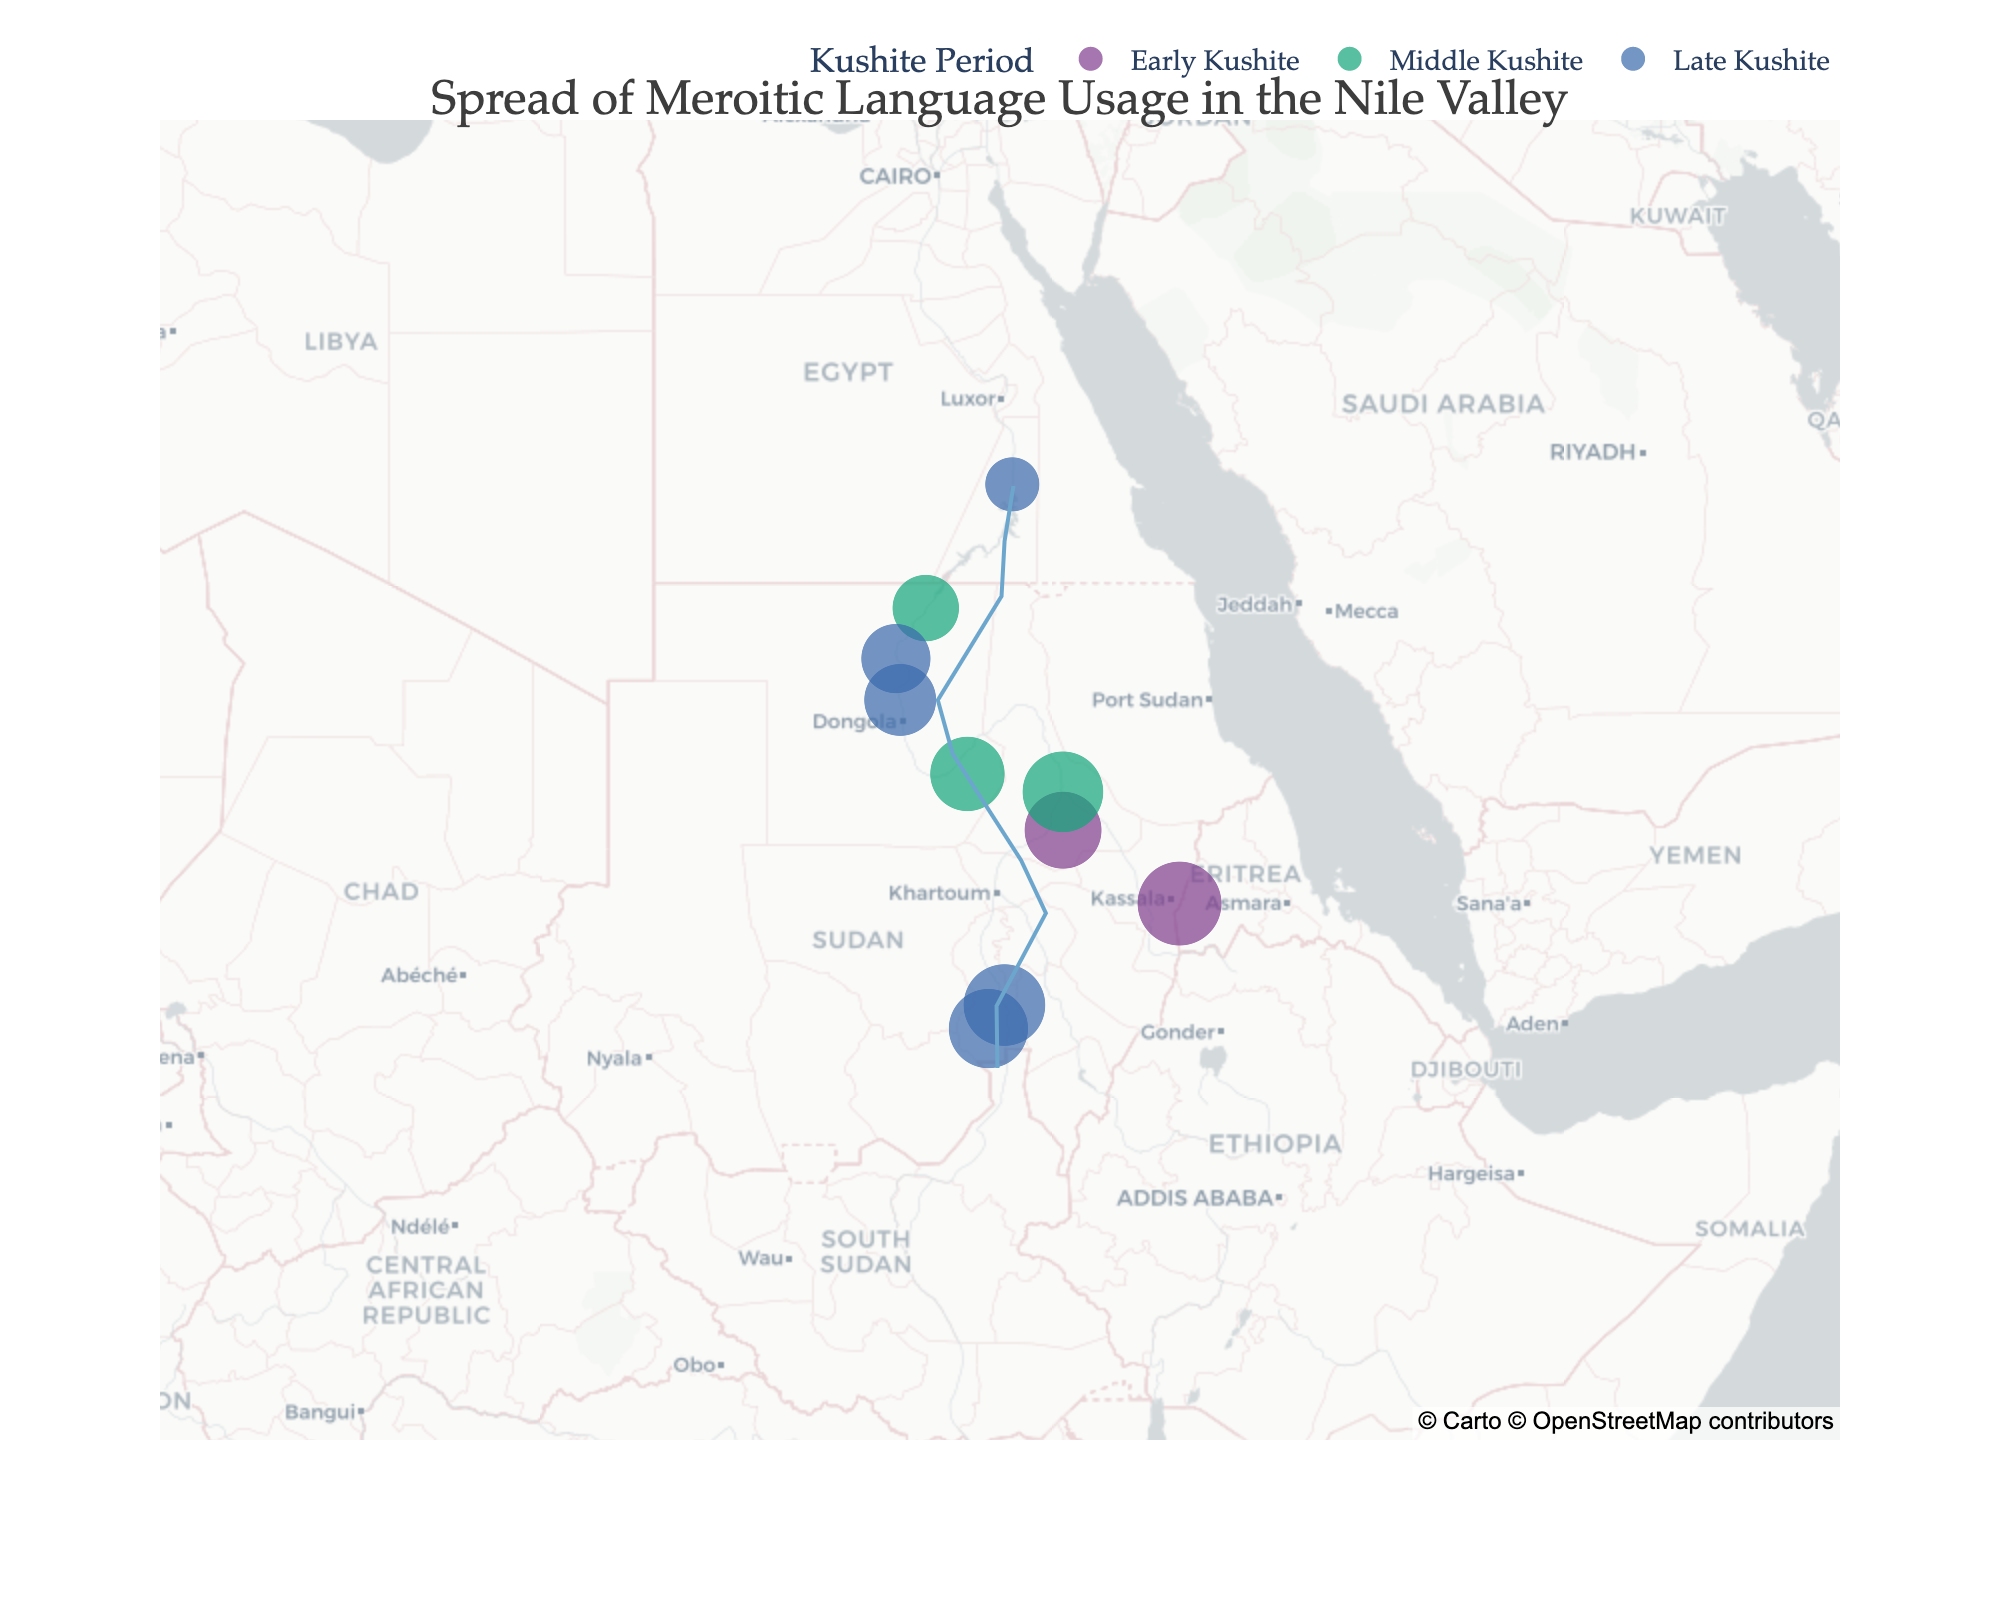How many locations are plotted on the map? By counting each distinct marker on the map, you can identify that there are 10 different locations plotted.
Answer: 10 Which location has the highest Meroitic language usage percentage? The location with the largest marker size represents the highest Meroitic usage percentage. In this case, Meroe has the highest with 95%.
Answer: Meroe How does the Meroitic language usage percentage at Meroe compare to Aswan? The Meroitic usage percentage for Meroe is 95%, and for Aswan, it is 40%. By comparing the two, Meroe has a significantly higher percentage.
Answer: Meroe is higher Which period has the most locations plotted? By counting the number of locations associated with each period, you can see the Late Kushite period has the most, with 5 locations.
Answer: Late Kushite What location has the smallest Meroitic usage percentage? Aswan has the smallest Meroitic usage percentage, displayed by the smallest marker size, which is 40%.
Answer: Aswan Which location is furthest north? By looking at the latitudes on the plot, Aswan at latitude 23.9936 is the furthest north.
Answer: Aswan Calculate the average Meroitic usage percentage for the Middle Kushite period. The Middle Kushite period has markers at Abu Simbel (60%), Kerma (75%), and Gebel Barkal (88%). The average is (60 + 75 + 88) / 3 = 74.33%.
Answer: 74.33% How does the Meroitic language usage in Napata compare to Faras during their respective periods? Napata in the Early Kushite period has 80%, and Faras in the Late Kushite period has 70%. Comparing both, Napata has a higher usage percentage.
Answer: Napata is higher Is Meroitic language usage more consistent in any particular period? The Meroitic usage percentages in the Late Kushite period (90%, 70%, 65%, 40%, 85%) have a wide range compared to the Early Kushite and Middle Kushite periods, suggesting less consistency.
Answer: Less consistent in Late Kushite Which marker is closest to the Nile River as plotted on the map? The marker at Gebel Barkal appears closest to the drawn line representing the Nile River.
Answer: Gebel Barkal 